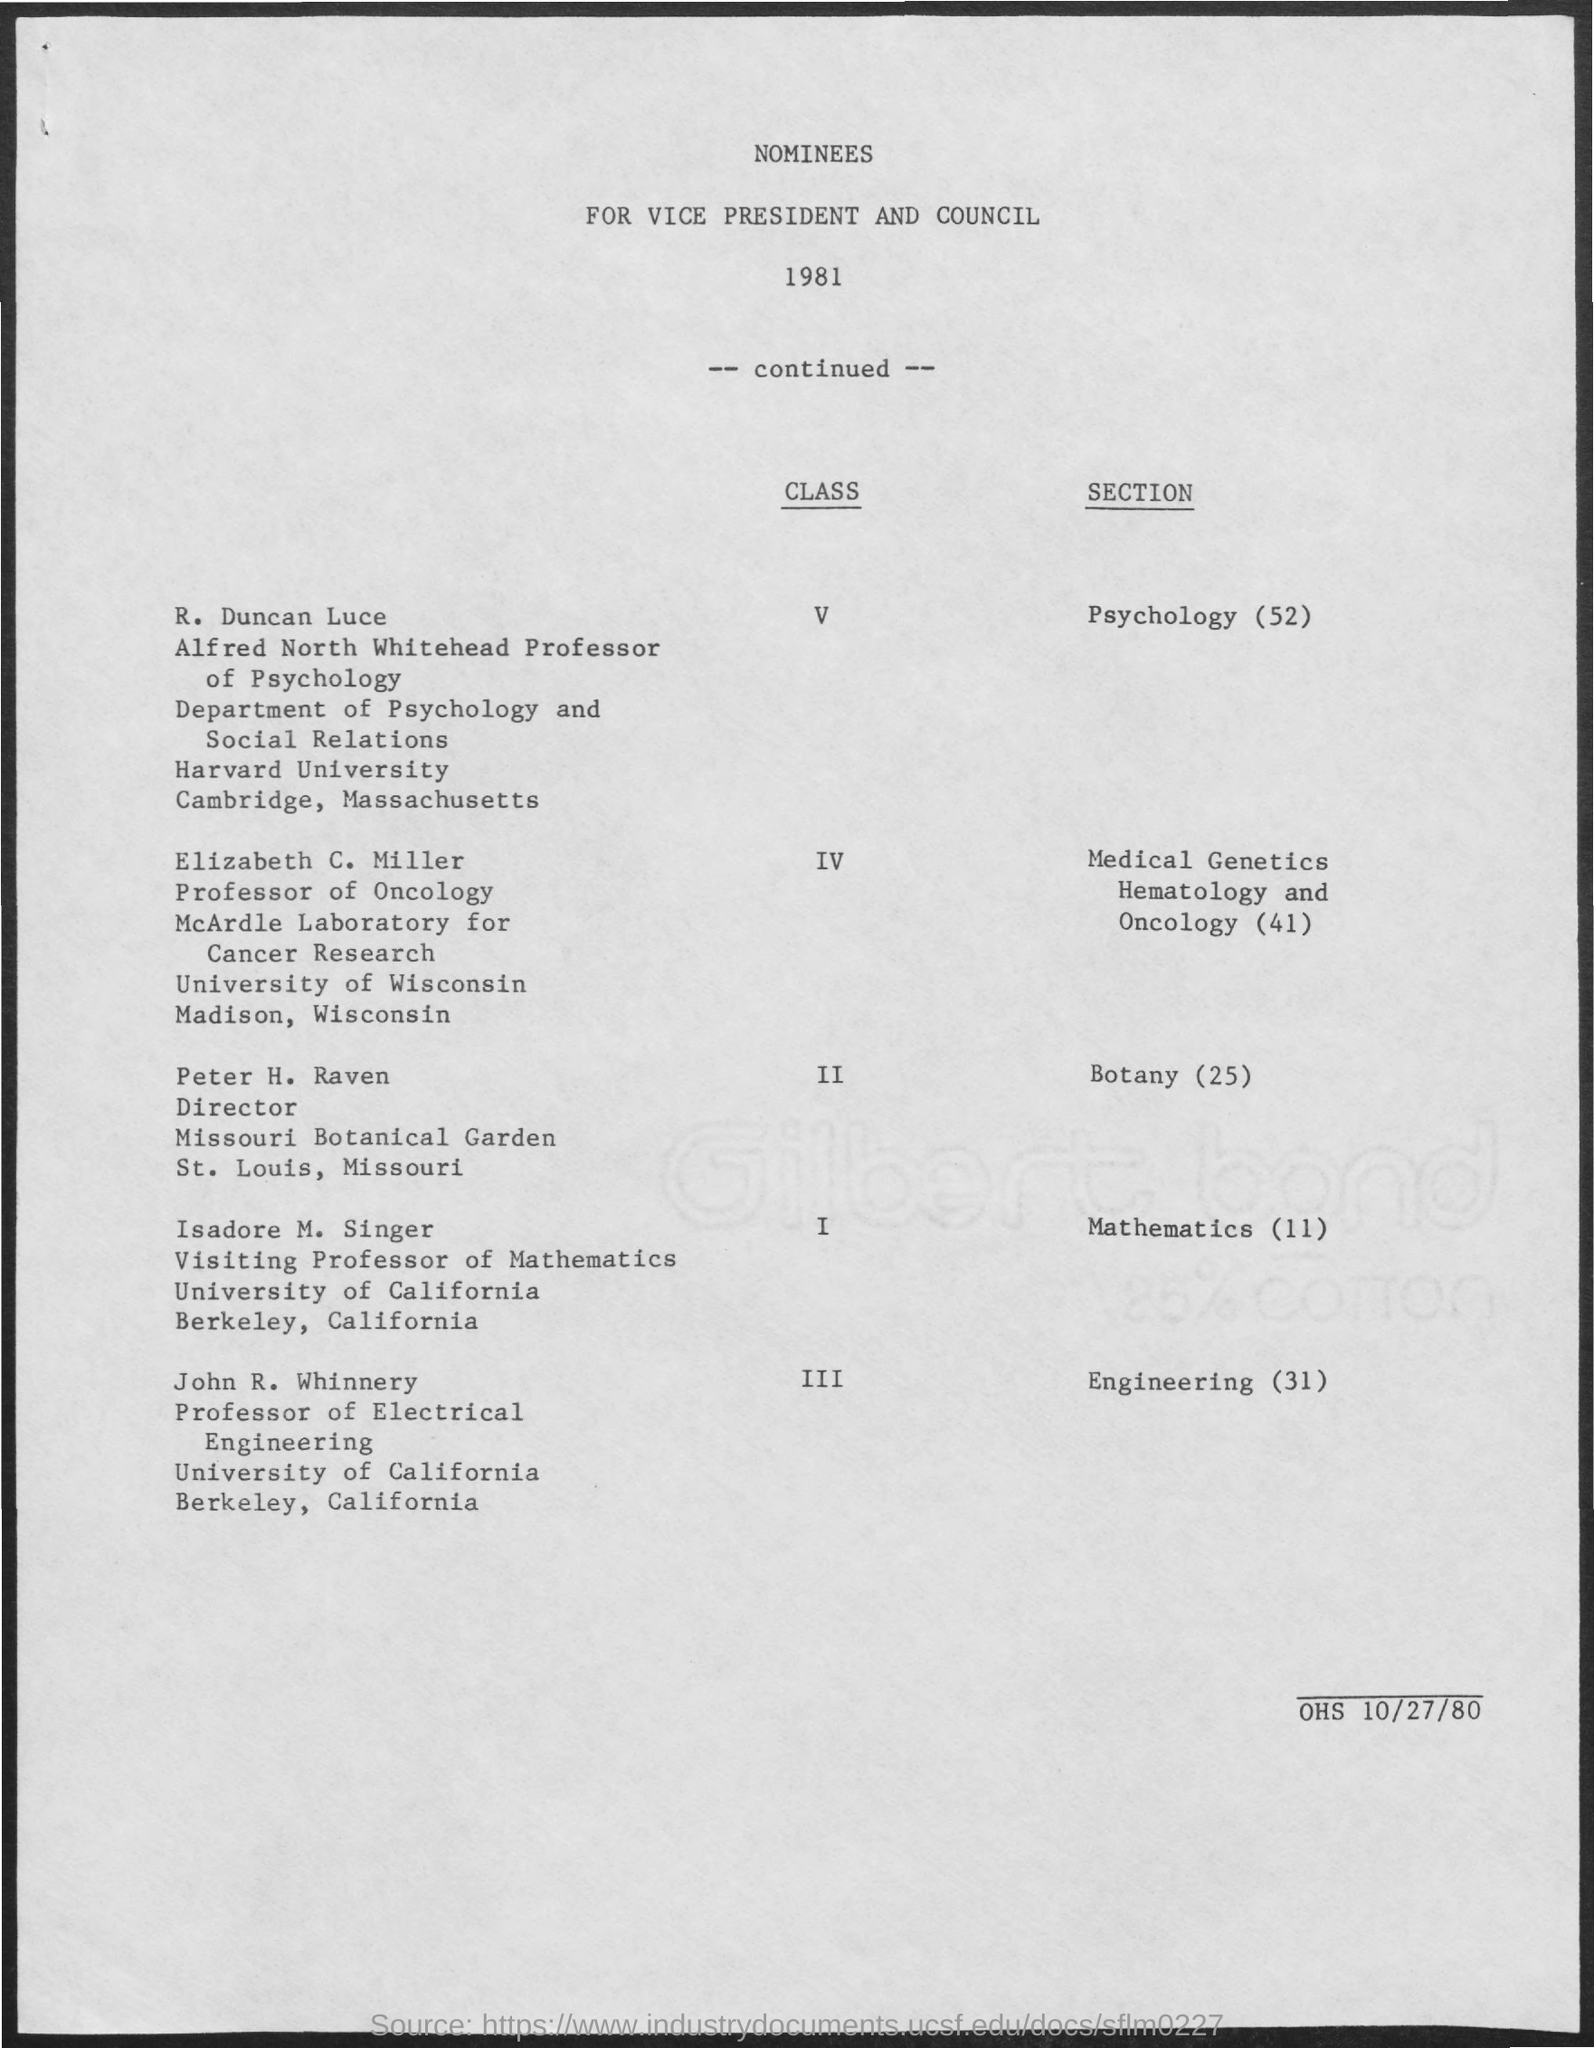What is the Year in the document?
Offer a very short reply. 1981. Which section is R. Duncan Luce in?
Offer a terse response. Psychology (52). Which section is Elizabeth C. Miller in?
Your response must be concise. Medical Genetics Hematology and Oncology (41). Which section is Peter H. Raven in?
Provide a short and direct response. Botany (25). Which section is Isadore M. Singer in?
Your answer should be very brief. Mathematics (11). Which section is John R. Whinnery in?
Your answer should be very brief. Engineering (31). Which Class is R. Duncan Luce in?
Offer a terse response. V. Which Class is Elizabeth C. Miller in?
Your answer should be compact. IV. Which Class is Peter H. Raven in?
Provide a succinct answer. II. Which Class is Isadore M. Singer in?
Keep it short and to the point. I. 